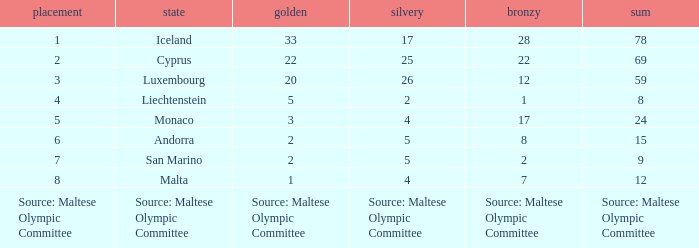What nation has 28 bronze medals? Iceland. 